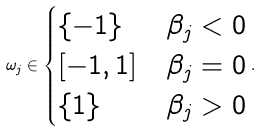<formula> <loc_0><loc_0><loc_500><loc_500>\omega _ { j } \in \begin{cases} \{ - 1 \} & \beta _ { j } < 0 \\ [ - 1 , 1 ] & \beta _ { j } = 0 \\ \{ 1 \} & \beta _ { j } > 0 \end{cases} .</formula> 